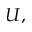Convert formula to latex. <formula><loc_0><loc_0><loc_500><loc_500>U ,</formula> 